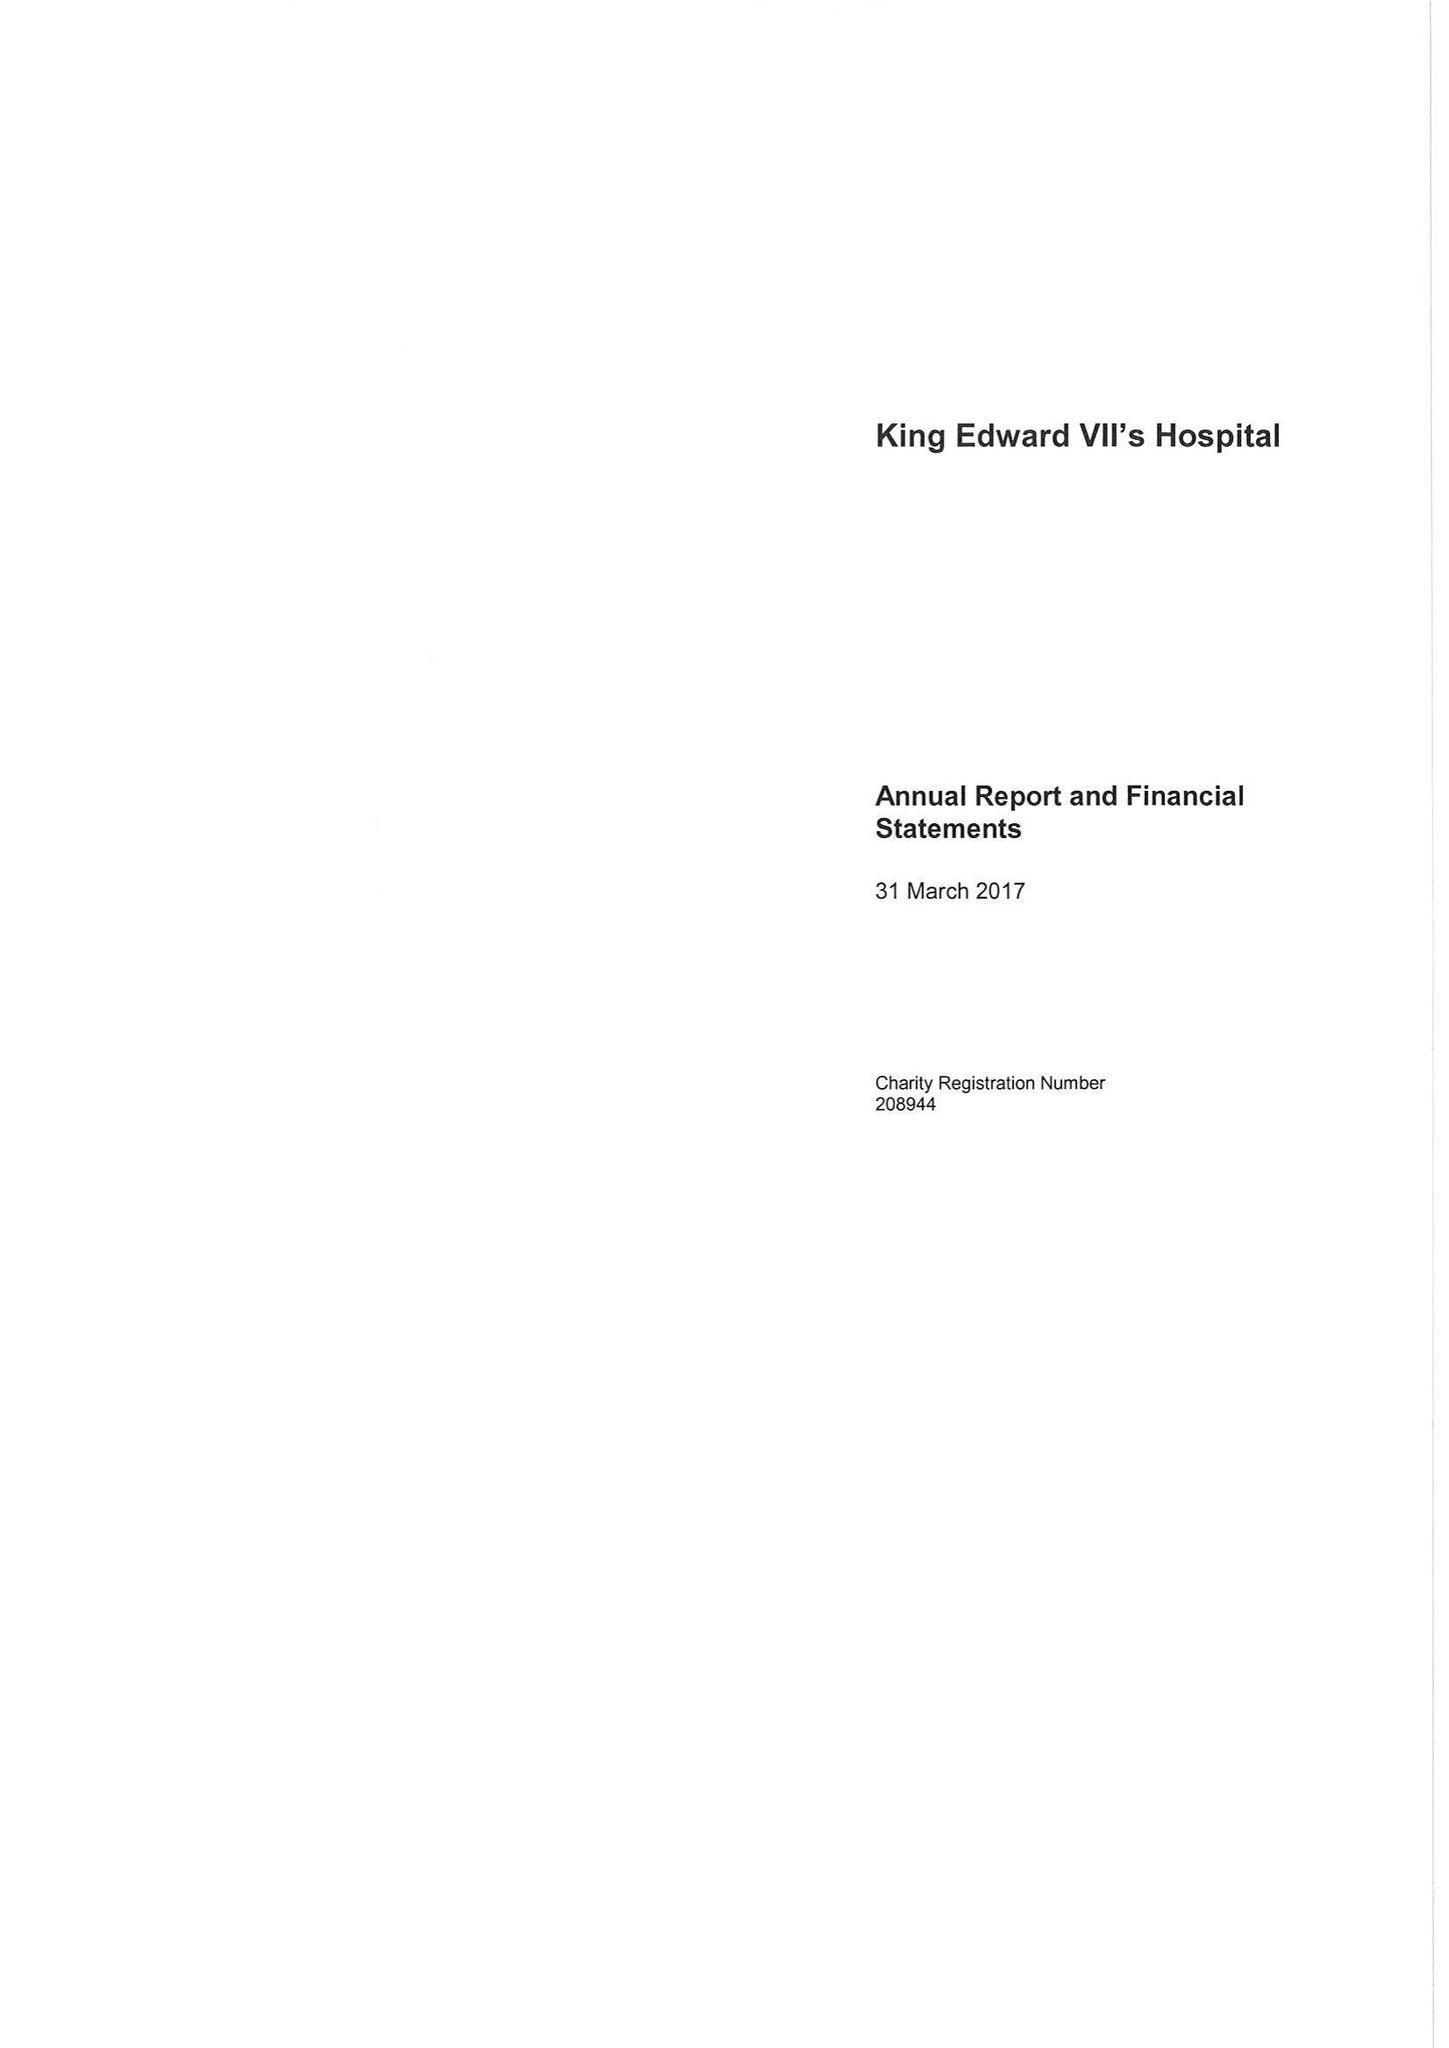What is the value for the spending_annually_in_british_pounds?
Answer the question using a single word or phrase. 26454000.00 